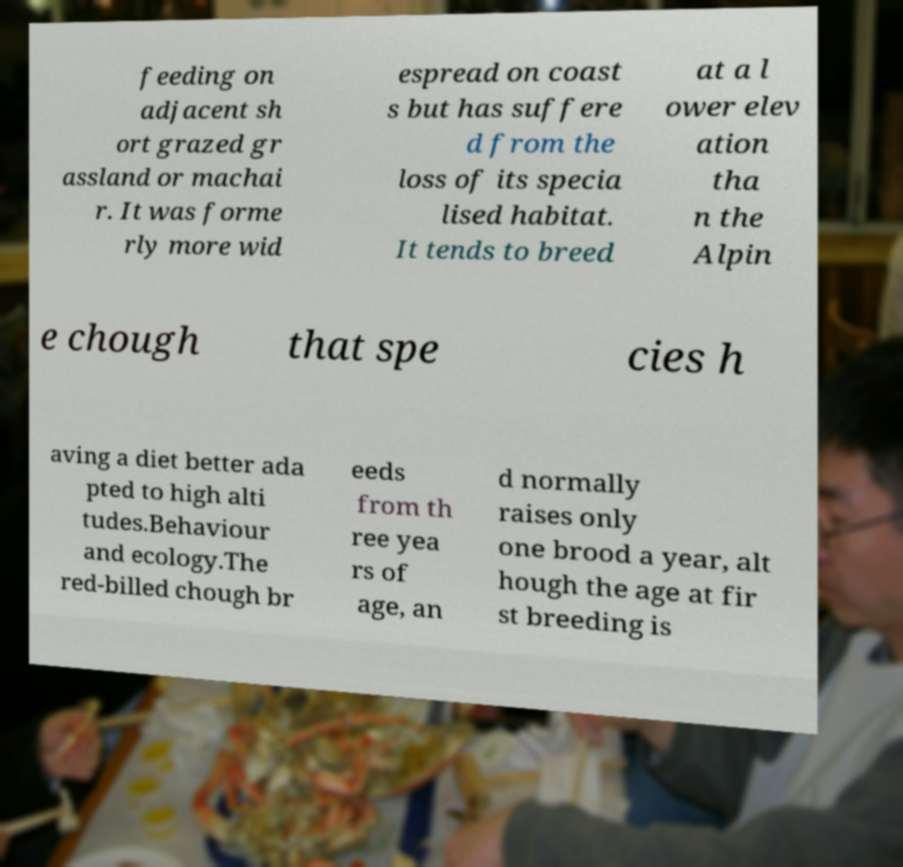What messages or text are displayed in this image? I need them in a readable, typed format. feeding on adjacent sh ort grazed gr assland or machai r. It was forme rly more wid espread on coast s but has suffere d from the loss of its specia lised habitat. It tends to breed at a l ower elev ation tha n the Alpin e chough that spe cies h aving a diet better ada pted to high alti tudes.Behaviour and ecology.The red-billed chough br eeds from th ree yea rs of age, an d normally raises only one brood a year, alt hough the age at fir st breeding is 